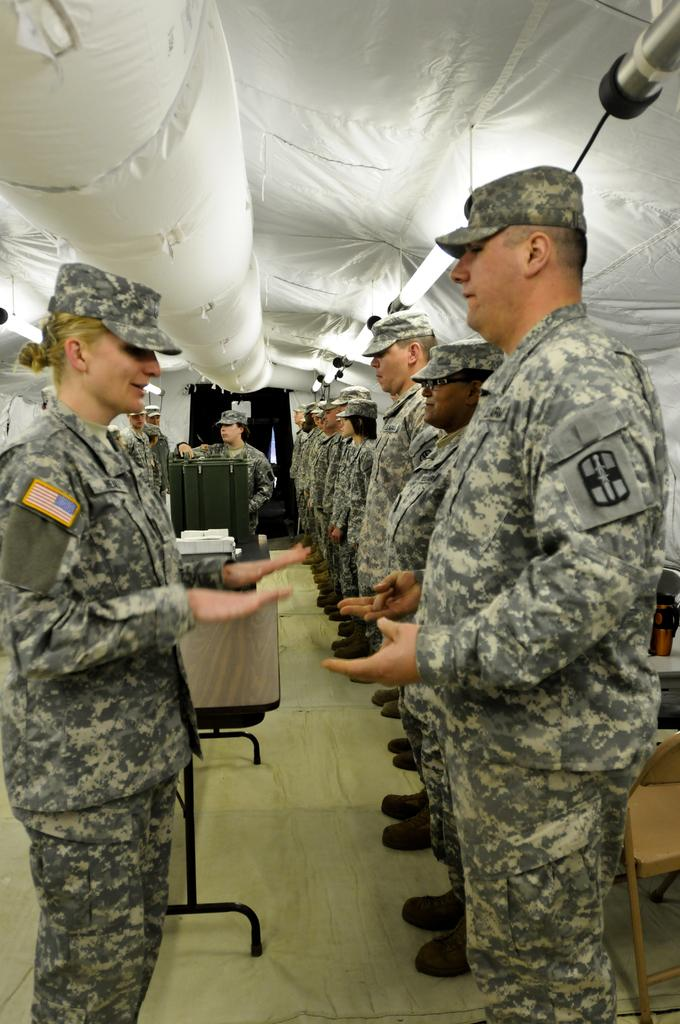What are the people in the image doing? The people in the image are standing in the center. What are the people wearing? The people are wearing uniforms. What can be seen at the top of the image? There is cloth visible at the top of the image. What is at the bottom of the image? There is a floor at the bottom of the image. What object is present in the image? There is a table in the image. What type of silver statement is being made by the people in the image? There is no silver or statement present in the image; the people are simply standing in uniforms. 